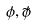Convert formula to latex. <formula><loc_0><loc_0><loc_500><loc_500>\phi , \tilde { \phi }</formula> 